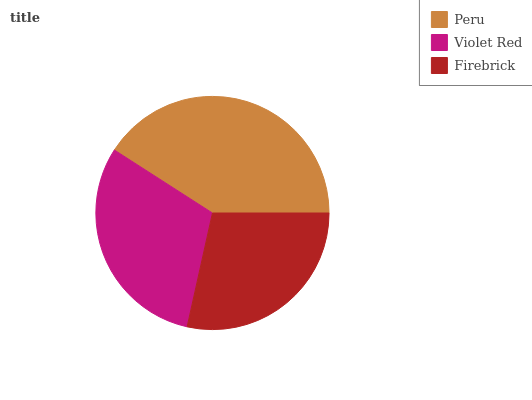Is Firebrick the minimum?
Answer yes or no. Yes. Is Peru the maximum?
Answer yes or no. Yes. Is Violet Red the minimum?
Answer yes or no. No. Is Violet Red the maximum?
Answer yes or no. No. Is Peru greater than Violet Red?
Answer yes or no. Yes. Is Violet Red less than Peru?
Answer yes or no. Yes. Is Violet Red greater than Peru?
Answer yes or no. No. Is Peru less than Violet Red?
Answer yes or no. No. Is Violet Red the high median?
Answer yes or no. Yes. Is Violet Red the low median?
Answer yes or no. Yes. Is Peru the high median?
Answer yes or no. No. Is Firebrick the low median?
Answer yes or no. No. 